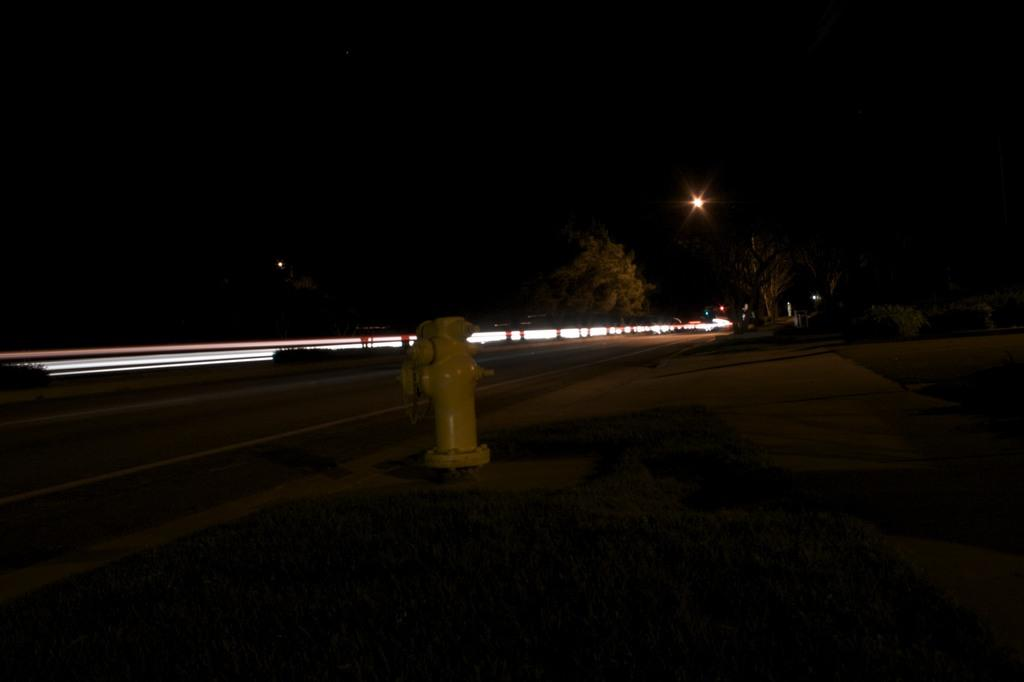What object can be seen in the image that is used for fire safety? There is a fire hydrant in the image. What type of surface is visible in the image? There is a road in the image. What can be seen illuminating the area in the image? There are lights in the image. What type of vegetation is present in the image? There are trees and bushes in the image. What type of ground cover is at the bottom of the image? There is grass at the bottom of the image. How would you describe the overall lighting in the image? The background of the image is dark. What type of instrument is being played by the tree in the image? There is no instrument being played by the tree in the image, as trees do not have the ability to play instruments. Can you describe the haircut of the grass in the image? The grass in the image does not have a haircut, as it is a natural ground cover and not a living being with hair. 